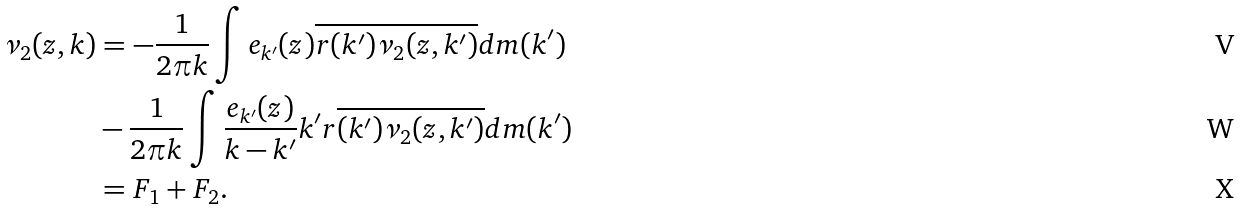<formula> <loc_0><loc_0><loc_500><loc_500>\nu _ { 2 } ( z , k ) & = - \frac { 1 } { 2 \pi k } \int e _ { k ^ { \prime } } ( z ) \overline { r ( k ^ { \prime } ) } \overline { \nu _ { 2 } ( z , k ^ { \prime } ) } d m ( k ^ { \prime } ) \\ & - \frac { 1 } { 2 \pi k } \int \frac { e _ { k ^ { \prime } } ( z ) } { k - k ^ { \prime } } k ^ { \prime } r \overline { ( k ^ { \prime } ) } \overline { \nu _ { 2 } ( z , k ^ { \prime } ) } d m ( k ^ { \prime } ) \\ & = F _ { 1 } + F _ { 2 } .</formula> 